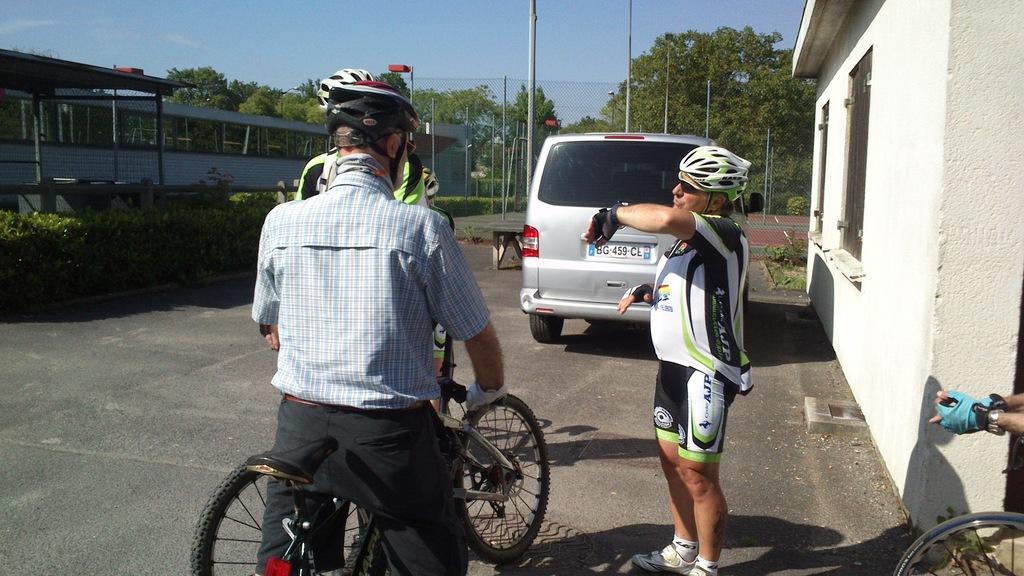Can you describe this image briefly? Here we can see a person sitting on the bicycle, and in front here a person is standing, and here the car is on the road, and here are the trees, and here is the fencing, and at above here is the sky. 